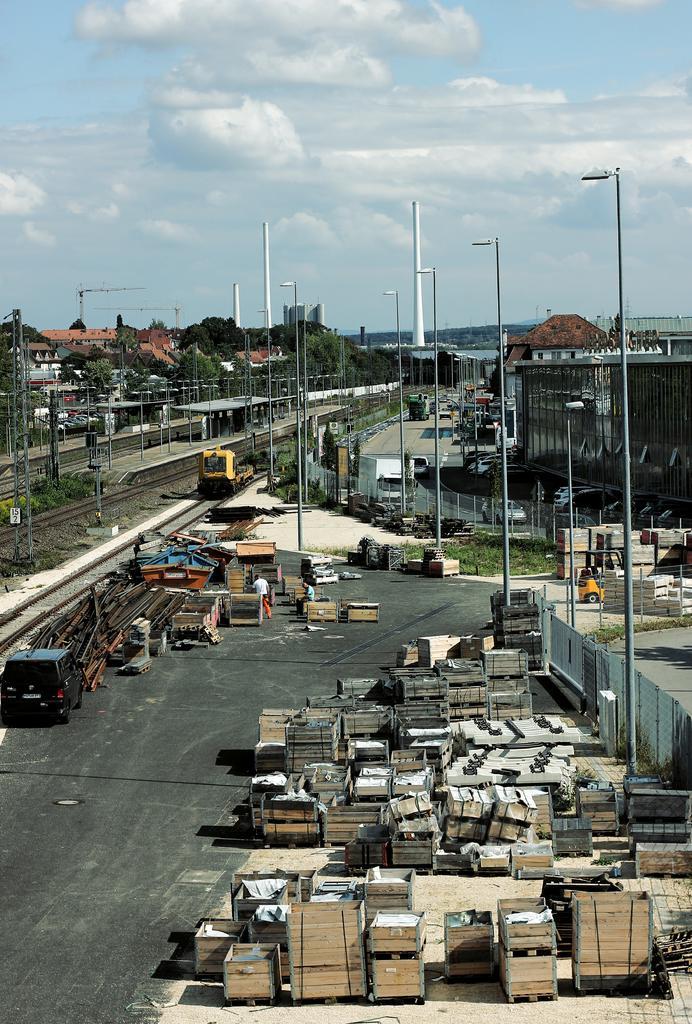Could you give a brief overview of what you see in this image? In this image there are buildings, train on the track, few objects on the road, trees, poles and the sky. 